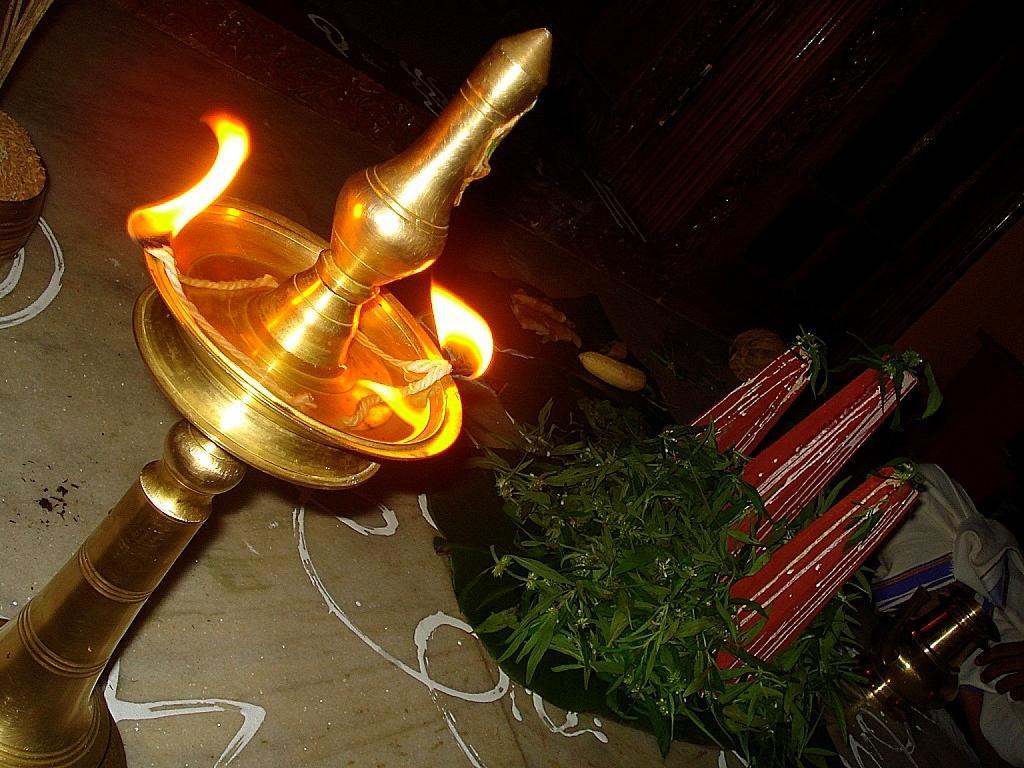In one or two sentences, can you explain what this image depicts? In this picture we can see a brass oil lamp with stand. There are plants and some food items. We can see some decorative items and other objects on the right side. We can see a few wooden objects and some objects on the left side. There is the hand of a person visible on the right side. 